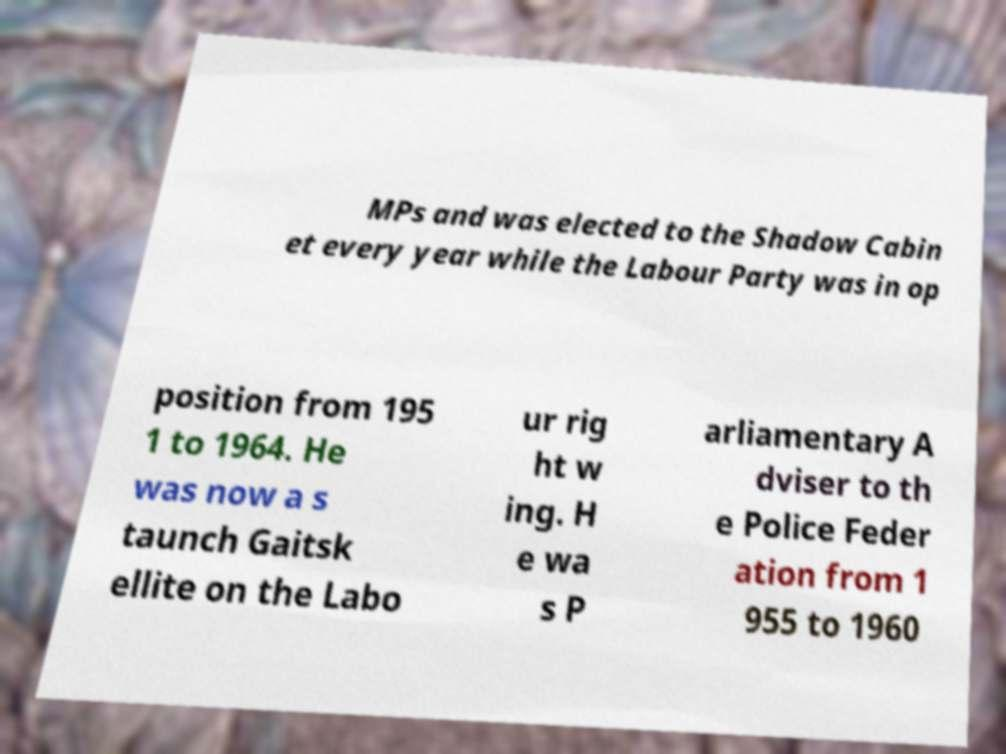Please identify and transcribe the text found in this image. MPs and was elected to the Shadow Cabin et every year while the Labour Party was in op position from 195 1 to 1964. He was now a s taunch Gaitsk ellite on the Labo ur rig ht w ing. H e wa s P arliamentary A dviser to th e Police Feder ation from 1 955 to 1960 